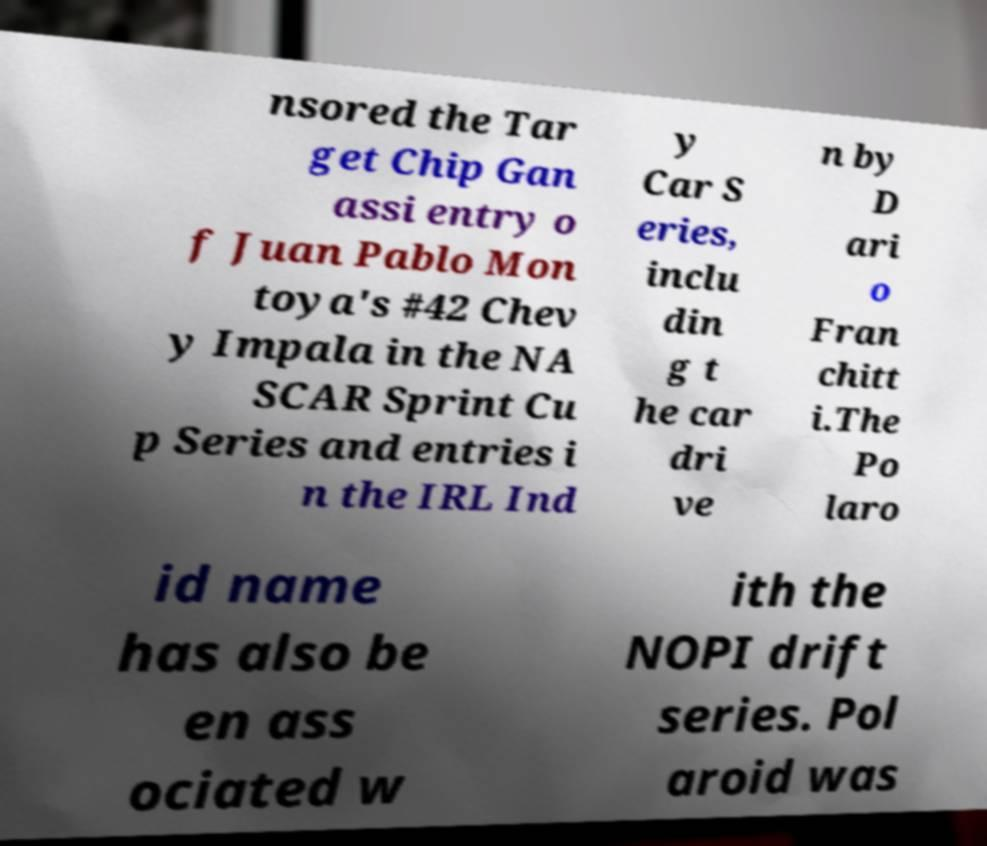For documentation purposes, I need the text within this image transcribed. Could you provide that? nsored the Tar get Chip Gan assi entry o f Juan Pablo Mon toya's #42 Chev y Impala in the NA SCAR Sprint Cu p Series and entries i n the IRL Ind y Car S eries, inclu din g t he car dri ve n by D ari o Fran chitt i.The Po laro id name has also be en ass ociated w ith the NOPI drift series. Pol aroid was 